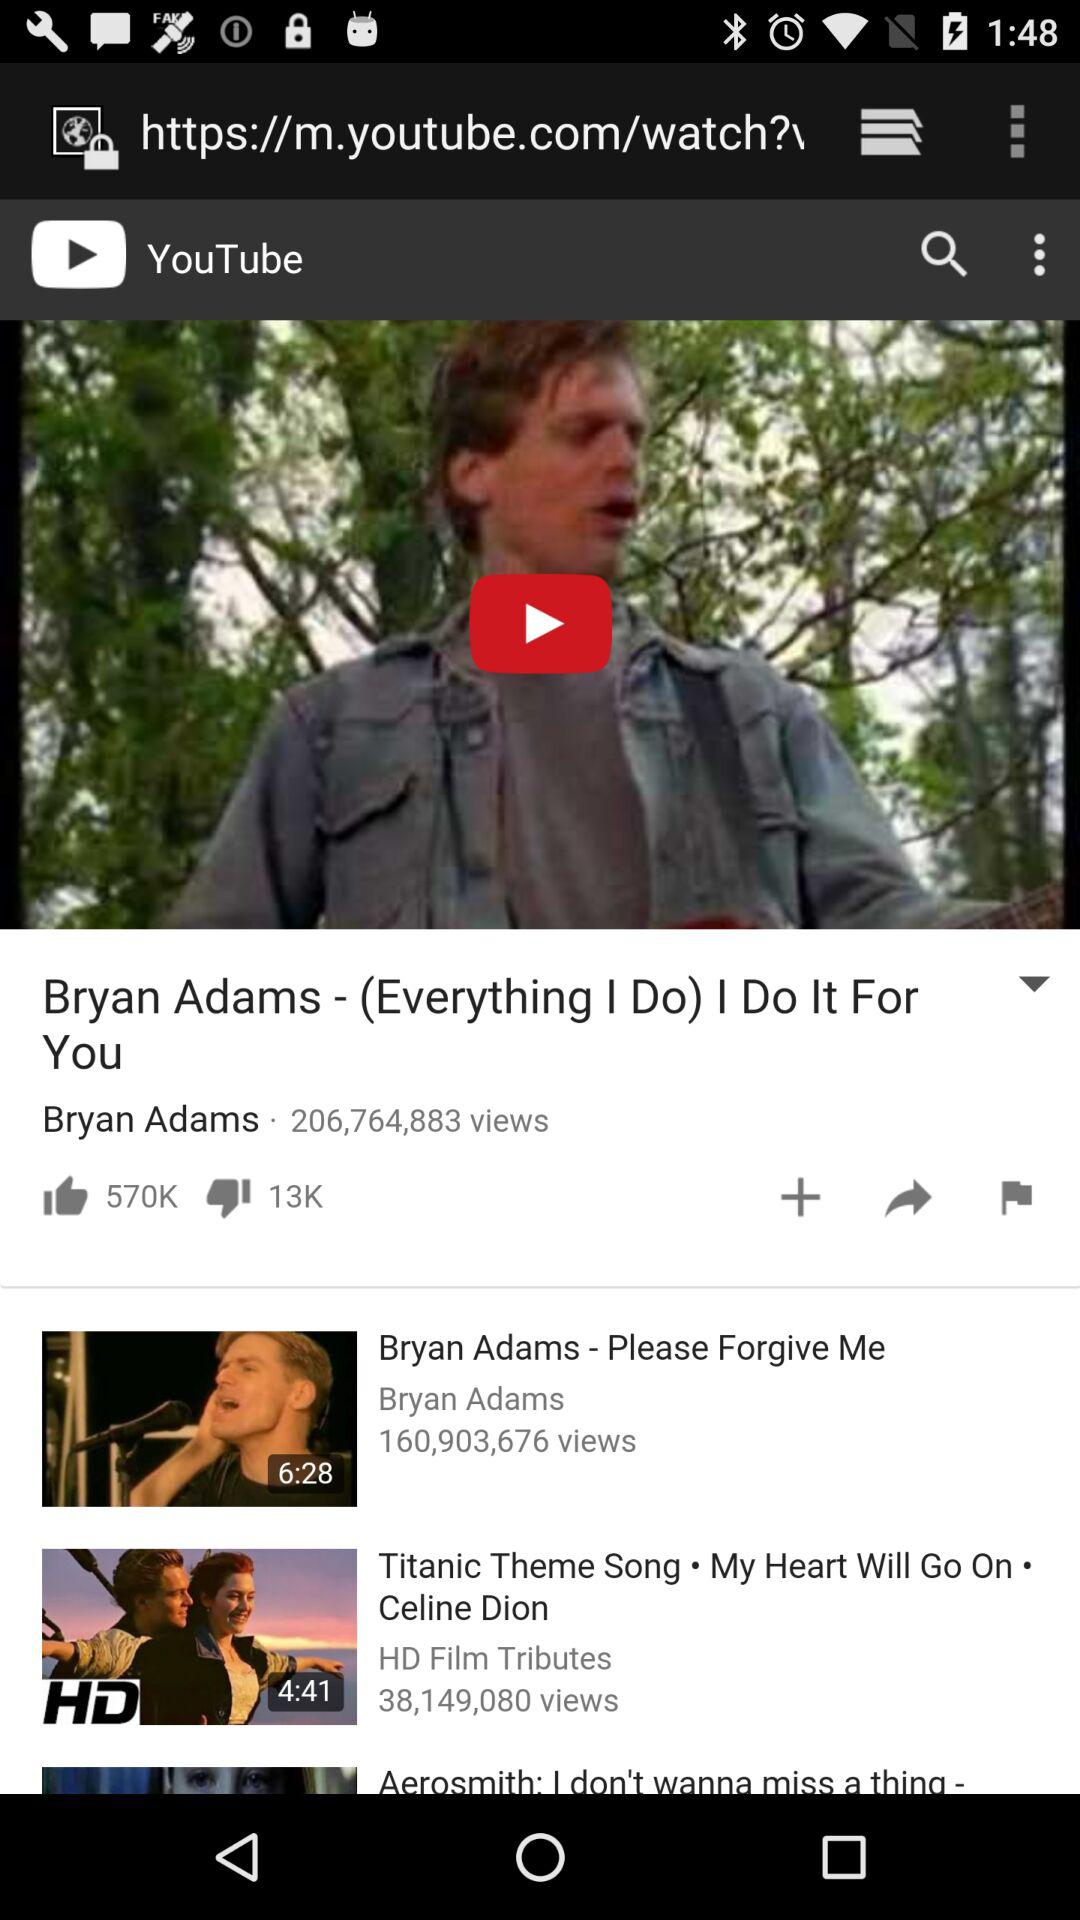How many people have viewed "Titanic Theme Song"? There are 38,149,080 people who have viewed "Titanic Theme Song". 